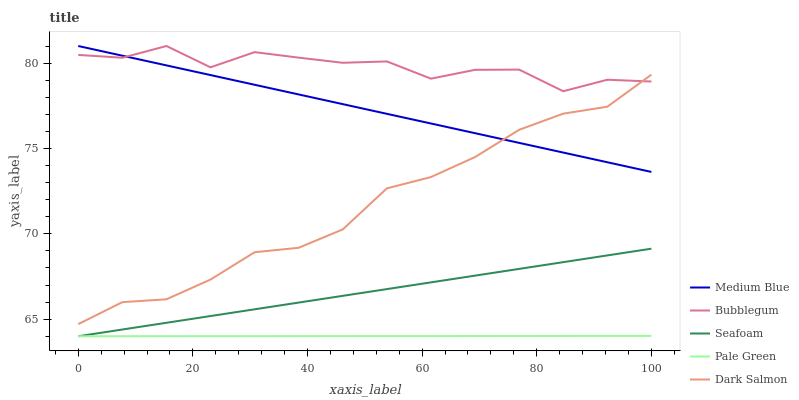Does Pale Green have the minimum area under the curve?
Answer yes or no. Yes. Does Bubblegum have the maximum area under the curve?
Answer yes or no. Yes. Does Medium Blue have the minimum area under the curve?
Answer yes or no. No. Does Medium Blue have the maximum area under the curve?
Answer yes or no. No. Is Seafoam the smoothest?
Answer yes or no. Yes. Is Bubblegum the roughest?
Answer yes or no. Yes. Is Medium Blue the smoothest?
Answer yes or no. No. Is Medium Blue the roughest?
Answer yes or no. No. Does Pale Green have the lowest value?
Answer yes or no. Yes. Does Medium Blue have the lowest value?
Answer yes or no. No. Does Bubblegum have the highest value?
Answer yes or no. Yes. Does Seafoam have the highest value?
Answer yes or no. No. Is Seafoam less than Bubblegum?
Answer yes or no. Yes. Is Dark Salmon greater than Seafoam?
Answer yes or no. Yes. Does Medium Blue intersect Dark Salmon?
Answer yes or no. Yes. Is Medium Blue less than Dark Salmon?
Answer yes or no. No. Is Medium Blue greater than Dark Salmon?
Answer yes or no. No. Does Seafoam intersect Bubblegum?
Answer yes or no. No. 